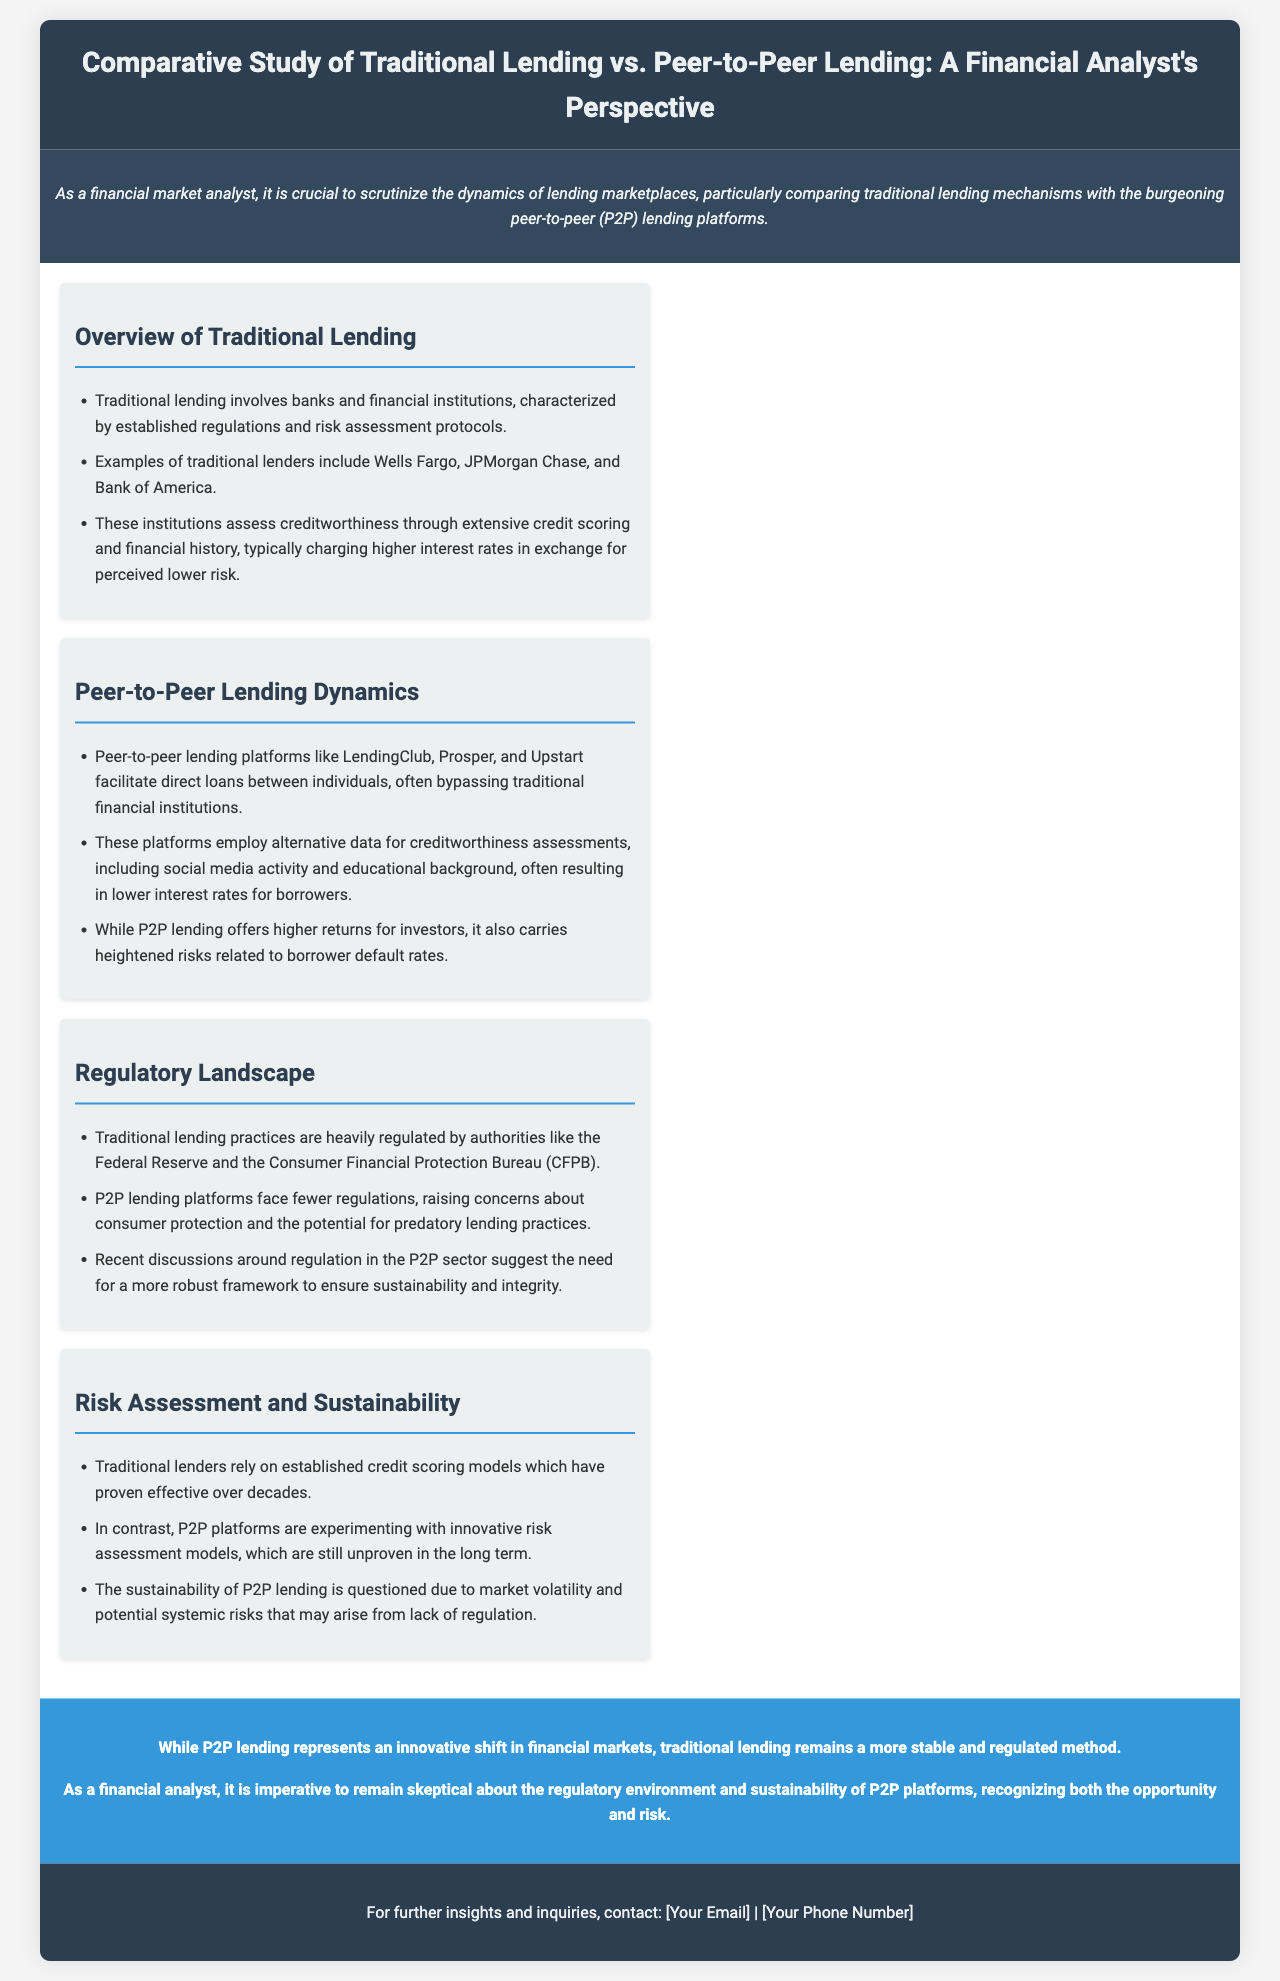What are some examples of traditional lenders? The document lists specific institutions that serve as examples of traditional lenders, demonstrating the established nature of this lending method.
Answer: Wells Fargo, JPMorgan Chase, Bank of America What is a characteristic of traditional lending? The document mentions a key feature of traditional lending practices, distinguishing them from peer-to-peer lending.
Answer: Established regulations Which platform is mentioned as a P2P lending example? The document cites specific platforms that exemplify peer-to-peer lending, showcasing the alternative lending landscape.
Answer: LendingClub What aspect of P2P lending raises concern? The document highlights a significant risk associated with peer-to-peer lending practices, questioning their sustainability and regulation.
Answer: Consumer protection How do P2P platforms assess creditworthiness? The document discusses the methods used by P2P platforms to evaluate borrowers, contrasting them with traditional credit assessment methods.
Answer: Alternative data What do traditional lenders rely on for risk assessment? The document specifies the method that traditional lenders use for evaluating credit risk, indicating its longevity and effectiveness.
Answer: Established credit scoring models What is a recent discussion in P2P lending? The document mentions ongoing conversations regarding improvements needed in the regulatory framework governing peer-to-peer platforms.
Answer: More robust framework How are interest rates typically compared between traditional and P2P lending? The document suggests a difference in lending costs based on the perceived risks involved in the two types of lending.
Answer: Lower interest rates for borrowers What is the conclusion regarding the stability of P2P lending? The document expresses concern about the overall longevity and safety of peer-to-peer lending compared to traditional methods.
Answer: More stable and regulated method 